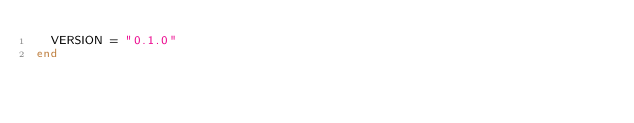<code> <loc_0><loc_0><loc_500><loc_500><_Crystal_>  VERSION = "0.1.0"
end
</code> 